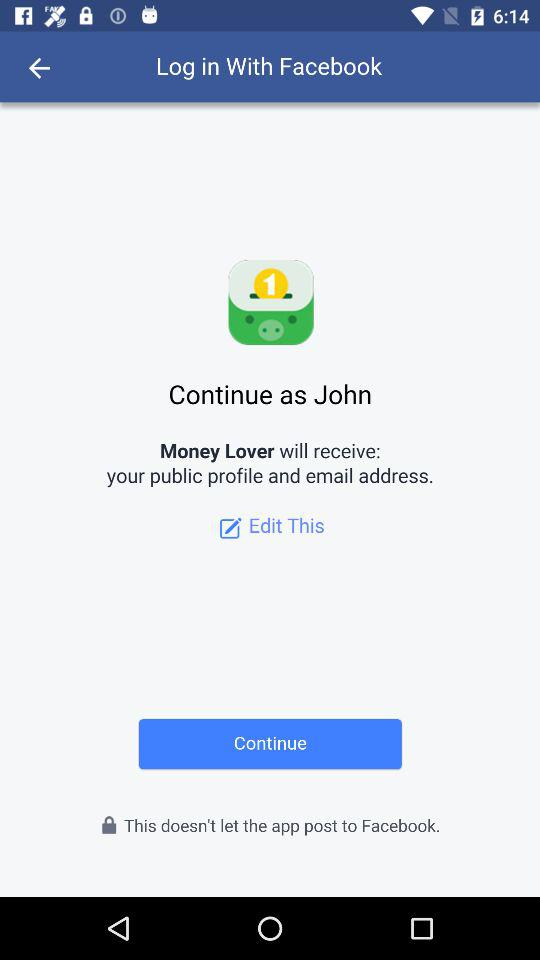What application will receive public profile and email address? The application will receive a public profile and the email address is "Money Lover". 